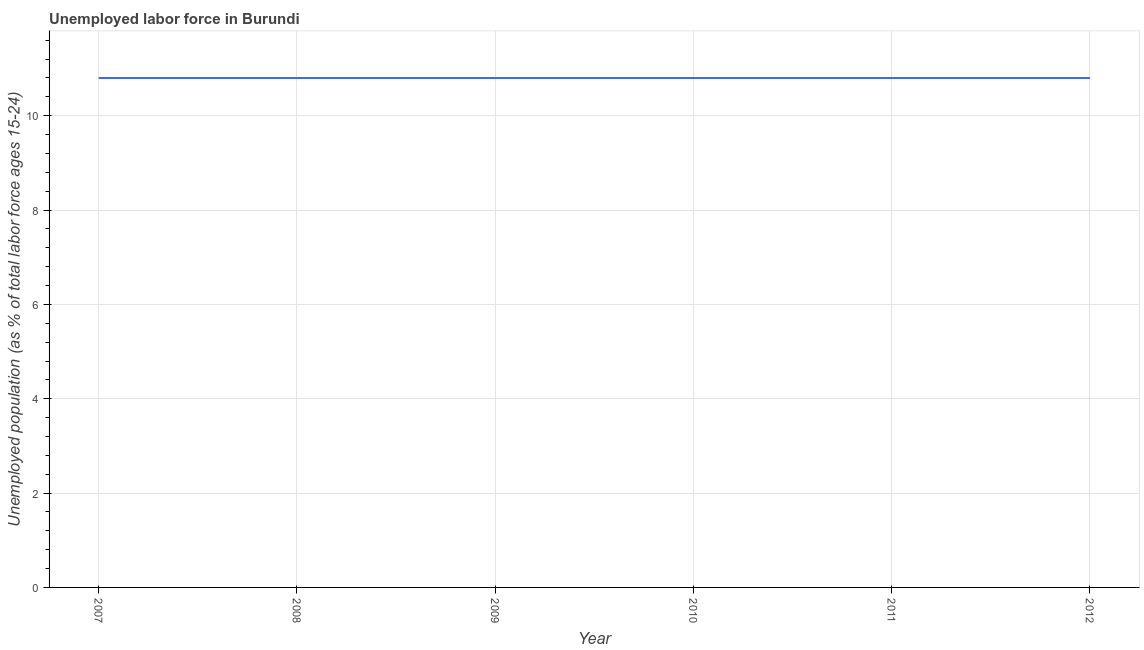What is the total unemployed youth population in 2011?
Offer a terse response. 10.8. Across all years, what is the maximum total unemployed youth population?
Keep it short and to the point. 10.8. Across all years, what is the minimum total unemployed youth population?
Your response must be concise. 10.8. In which year was the total unemployed youth population minimum?
Provide a short and direct response. 2007. What is the sum of the total unemployed youth population?
Give a very brief answer. 64.8. What is the average total unemployed youth population per year?
Make the answer very short. 10.8. What is the median total unemployed youth population?
Keep it short and to the point. 10.8. Do a majority of the years between 2007 and 2008 (inclusive) have total unemployed youth population greater than 10.8 %?
Provide a succinct answer. Yes. Is the total unemployed youth population in 2007 less than that in 2011?
Offer a terse response. No. What is the difference between the highest and the second highest total unemployed youth population?
Make the answer very short. 0. In how many years, is the total unemployed youth population greater than the average total unemployed youth population taken over all years?
Make the answer very short. 0. Does the total unemployed youth population monotonically increase over the years?
Provide a succinct answer. No. What is the difference between two consecutive major ticks on the Y-axis?
Provide a short and direct response. 2. Does the graph contain any zero values?
Give a very brief answer. No. What is the title of the graph?
Ensure brevity in your answer.  Unemployed labor force in Burundi. What is the label or title of the X-axis?
Provide a short and direct response. Year. What is the label or title of the Y-axis?
Your response must be concise. Unemployed population (as % of total labor force ages 15-24). What is the Unemployed population (as % of total labor force ages 15-24) in 2007?
Make the answer very short. 10.8. What is the Unemployed population (as % of total labor force ages 15-24) in 2008?
Give a very brief answer. 10.8. What is the Unemployed population (as % of total labor force ages 15-24) in 2009?
Make the answer very short. 10.8. What is the Unemployed population (as % of total labor force ages 15-24) in 2010?
Ensure brevity in your answer.  10.8. What is the Unemployed population (as % of total labor force ages 15-24) of 2011?
Provide a succinct answer. 10.8. What is the Unemployed population (as % of total labor force ages 15-24) in 2012?
Keep it short and to the point. 10.8. What is the difference between the Unemployed population (as % of total labor force ages 15-24) in 2007 and 2008?
Give a very brief answer. 0. What is the difference between the Unemployed population (as % of total labor force ages 15-24) in 2007 and 2009?
Offer a very short reply. 0. What is the difference between the Unemployed population (as % of total labor force ages 15-24) in 2007 and 2010?
Your response must be concise. 0. What is the difference between the Unemployed population (as % of total labor force ages 15-24) in 2007 and 2011?
Provide a succinct answer. 0. What is the difference between the Unemployed population (as % of total labor force ages 15-24) in 2008 and 2009?
Your response must be concise. 0. What is the difference between the Unemployed population (as % of total labor force ages 15-24) in 2008 and 2010?
Offer a very short reply. 0. What is the difference between the Unemployed population (as % of total labor force ages 15-24) in 2009 and 2011?
Ensure brevity in your answer.  0. What is the difference between the Unemployed population (as % of total labor force ages 15-24) in 2010 and 2011?
Your answer should be compact. 0. What is the difference between the Unemployed population (as % of total labor force ages 15-24) in 2010 and 2012?
Offer a very short reply. 0. What is the difference between the Unemployed population (as % of total labor force ages 15-24) in 2011 and 2012?
Offer a terse response. 0. What is the ratio of the Unemployed population (as % of total labor force ages 15-24) in 2007 to that in 2008?
Provide a succinct answer. 1. What is the ratio of the Unemployed population (as % of total labor force ages 15-24) in 2007 to that in 2009?
Your answer should be very brief. 1. What is the ratio of the Unemployed population (as % of total labor force ages 15-24) in 2007 to that in 2010?
Keep it short and to the point. 1. What is the ratio of the Unemployed population (as % of total labor force ages 15-24) in 2007 to that in 2012?
Keep it short and to the point. 1. What is the ratio of the Unemployed population (as % of total labor force ages 15-24) in 2008 to that in 2009?
Offer a terse response. 1. What is the ratio of the Unemployed population (as % of total labor force ages 15-24) in 2008 to that in 2010?
Your response must be concise. 1. What is the ratio of the Unemployed population (as % of total labor force ages 15-24) in 2008 to that in 2011?
Ensure brevity in your answer.  1. What is the ratio of the Unemployed population (as % of total labor force ages 15-24) in 2009 to that in 2010?
Give a very brief answer. 1. What is the ratio of the Unemployed population (as % of total labor force ages 15-24) in 2009 to that in 2011?
Your answer should be very brief. 1. 